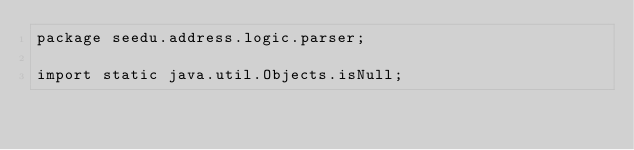<code> <loc_0><loc_0><loc_500><loc_500><_Java_>package seedu.address.logic.parser;

import static java.util.Objects.isNull;</code> 